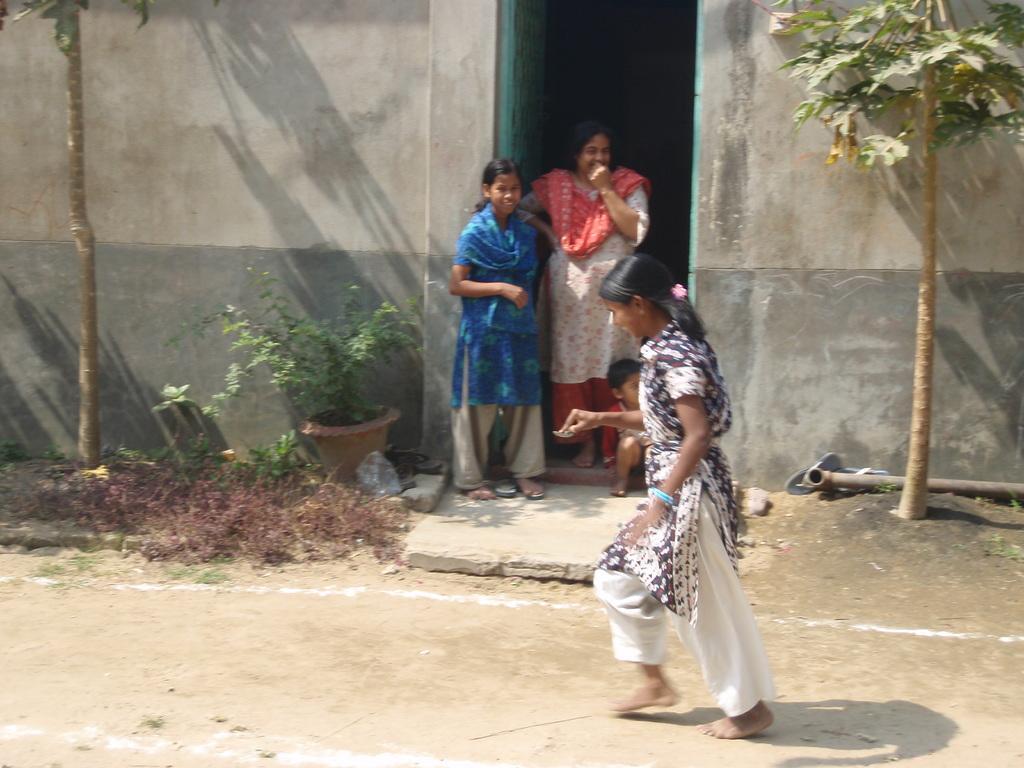Can you describe this image briefly? This image consists of four persons. In the front, the girl is playing a game. At the bottom, there is a ground. On the left and right, there are small trees. And there is a potted plants. In the front, there is a door along with the wall. 